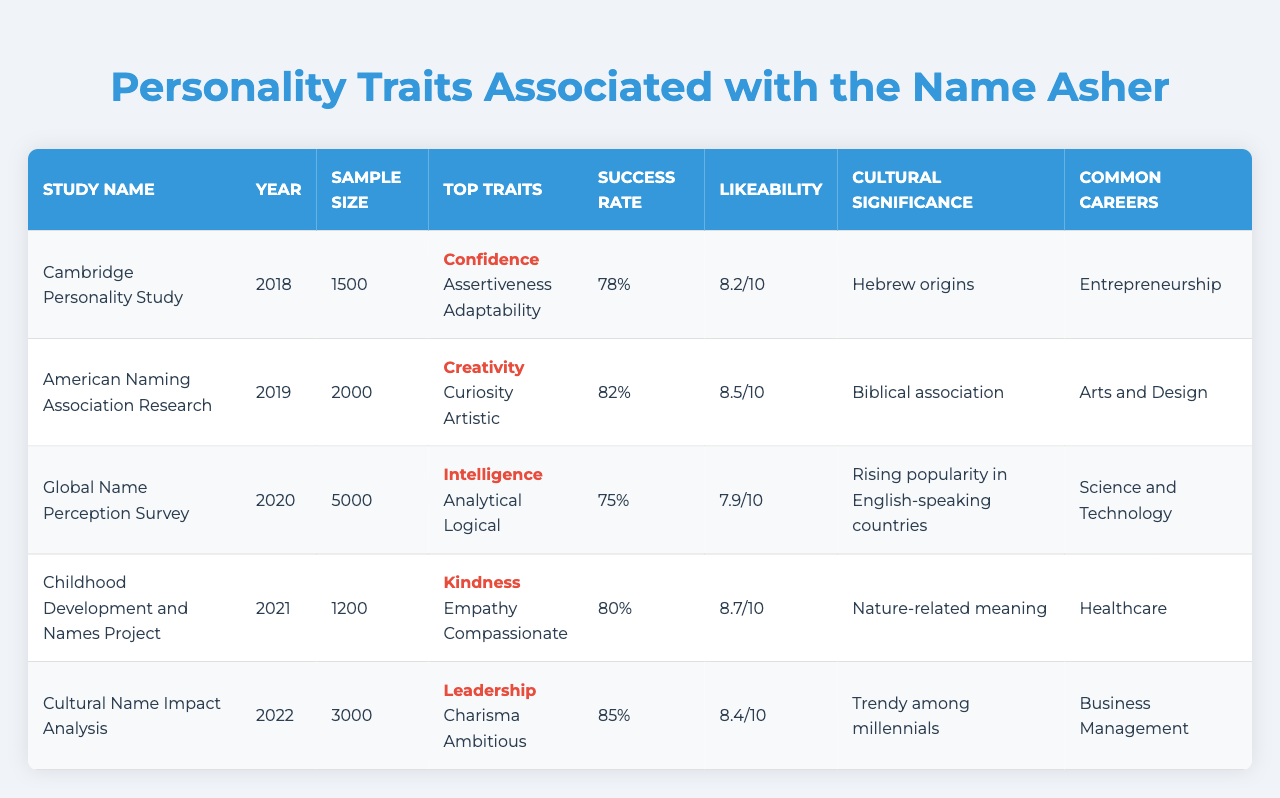What is the top personality trait associated with the name Asher according to the Cambridge Personality Study? The chapter indicates that the top personality trait for the Cambridge Personality Study is "Confidence".
Answer: Confidence In which year was the Global Name Perception Survey conducted? The table clearly states that the Global Name Perception Survey was conducted in the year 2020.
Answer: 2020 What was the perceived success rate in the Childhood Development and Names Project? According to the table, the perceived success rate for the Childhood Development and Names Project is 80%.
Answer: 80% Which study shows the highest likeability score? By comparing the likeability scores across studies, the Cultural Name Impact Analysis has the highest score of 8.4.
Answer: 8.4 What are the common career paths associated with the name Asher according to the American Naming Association Research? The table lists "Arts and Design" as the common career path related to this study.
Answer: Arts and Design Which study reports the lowest perceived success rate? The Global Name Perception Survey reports the lowest perceived success rate at 75%.
Answer: 75% If the sample sizes from all studies are added together, what is the total? Adding the sample sizes gives a total of 1500 + 2000 + 5000 + 1200 + 3000 = 11700.
Answer: 11700 Which top personality trait is associated with the highest perceived success rate? By looking at the data, "Leadership" from the Cultural Name Impact Analysis has the highest perceived success rate of 85%.
Answer: Leadership Is the secondary trait "Curiosity" found in any studies? Yes, the secondary trait "Curiosity" is associated with the American Naming Association Research.
Answer: Yes What is the average likeability score across all studies? The average is calculated by adding the likeability scores (8.2 + 8.5 + 7.9 + 8.7 + 8.4) = 41.7, which is then divided by 5, yielding an average of 8.34.
Answer: 8.34 How does the top personality trait differ between the Childhood Development and Names Project and the Cultural Name Impact Analysis? The Childhood Development and Names Project emphasizes "Kindness" while the Cultural Name Impact Analysis highlights "Leadership" as the top trait.
Answer: Kindness vs. Leadership Is there a correlation between the sample size and the perceived success rate? A quick visual inspection suggests that larger sample sizes do not correlate with higher perceived success rates; for example, the largest study (Global Name Perception Survey) has a lower success rate than smaller studies.
Answer: No correlation 